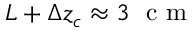<formula> <loc_0><loc_0><loc_500><loc_500>L + \Delta z _ { c } \approx 3 c m</formula> 